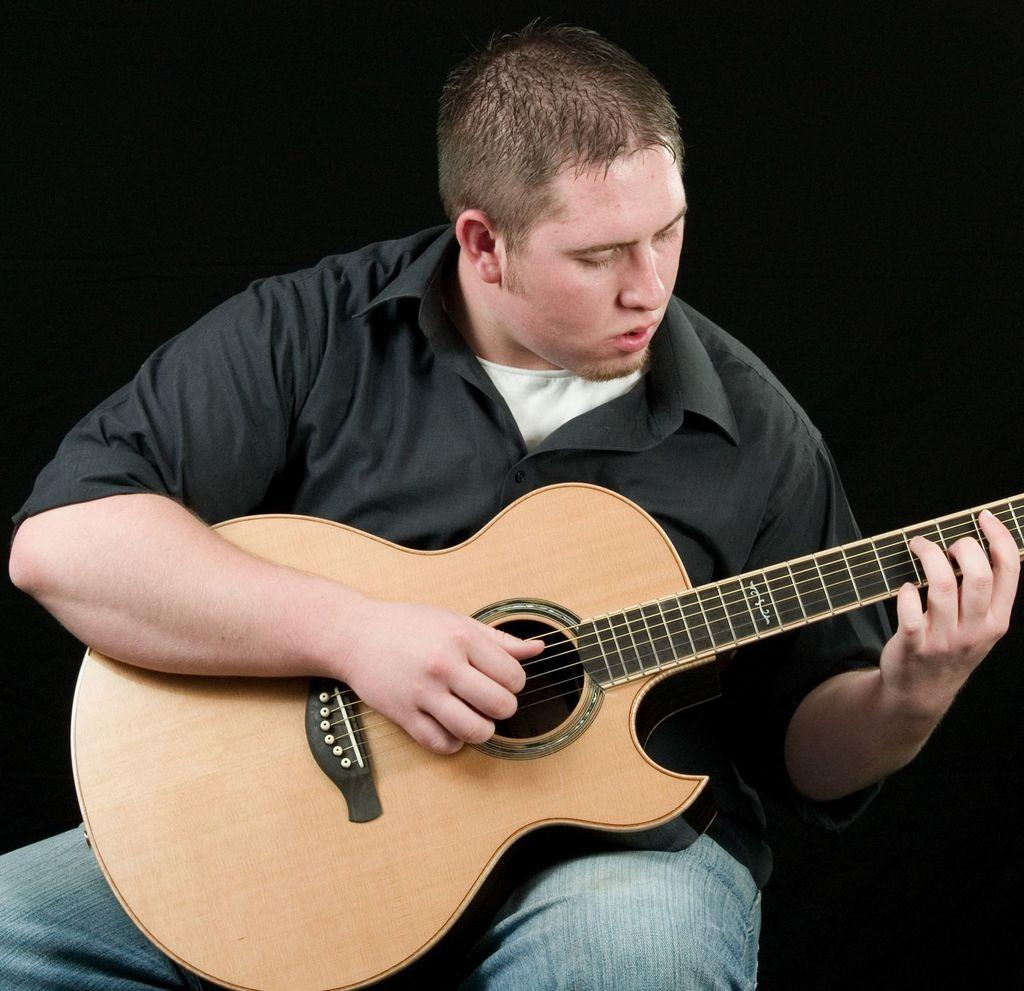What is the man in the image doing? The man is playing a guitar. What is the man wearing in the image? The man is wearing a black shirt. What type of house is visible in the background of the image? There is no house visible in the background of the image. What treatment is the man receiving for his guitar playing in the image? The man is not receiving any treatment for his guitar playing in the image; he is simply playing the guitar. 